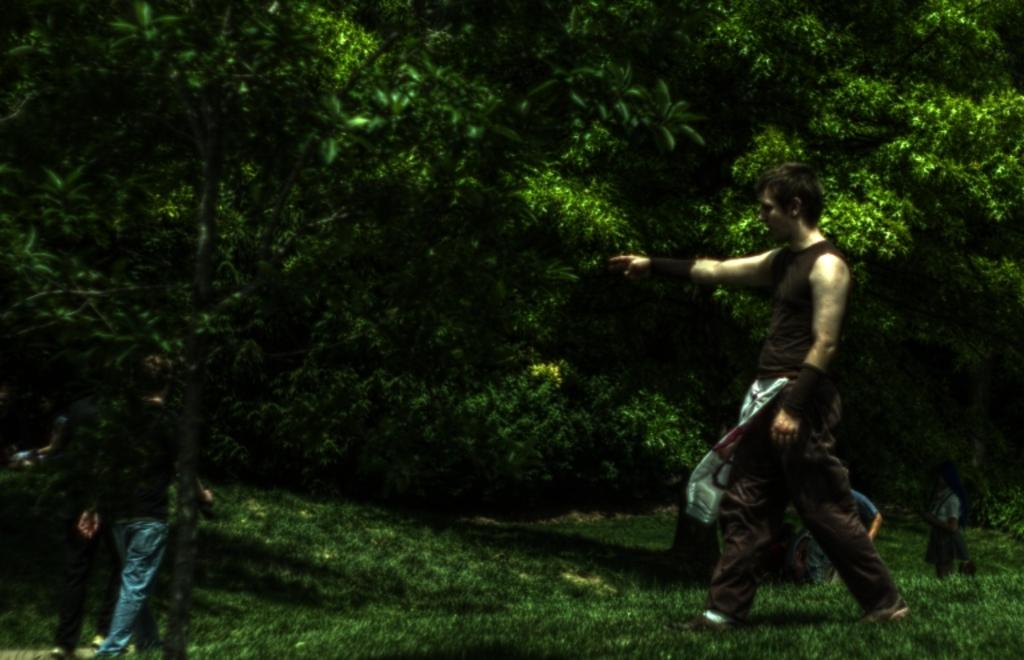What is the man in the image doing? The man in the image is walking on the grass surface. Can you describe the other person in the image? The other person is standing near a tree in the image. What can be seen in the background of the image? Trees and plants are visible in the background of the image. What type of jar is hanging from the tree in the image? There is no jar present in the image; it only features a man walking on the grass and another person standing near a tree. What angle is the stocking being worn at in the image? There is no mention of a stocking in the image, so it cannot be determined what angle it might be worn at. 